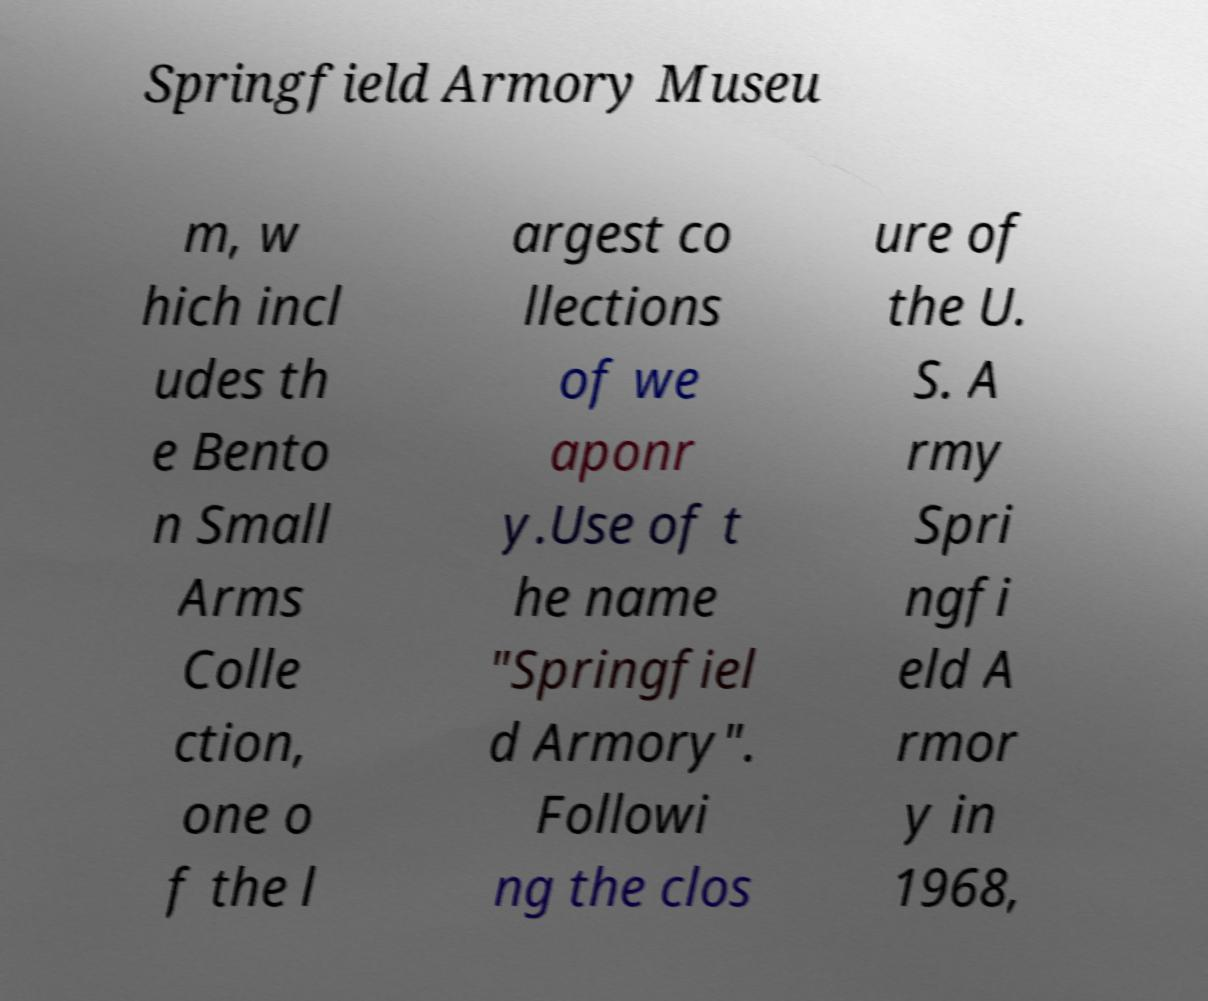Could you assist in decoding the text presented in this image and type it out clearly? Springfield Armory Museu m, w hich incl udes th e Bento n Small Arms Colle ction, one o f the l argest co llections of we aponr y.Use of t he name "Springfiel d Armory". Followi ng the clos ure of the U. S. A rmy Spri ngfi eld A rmor y in 1968, 